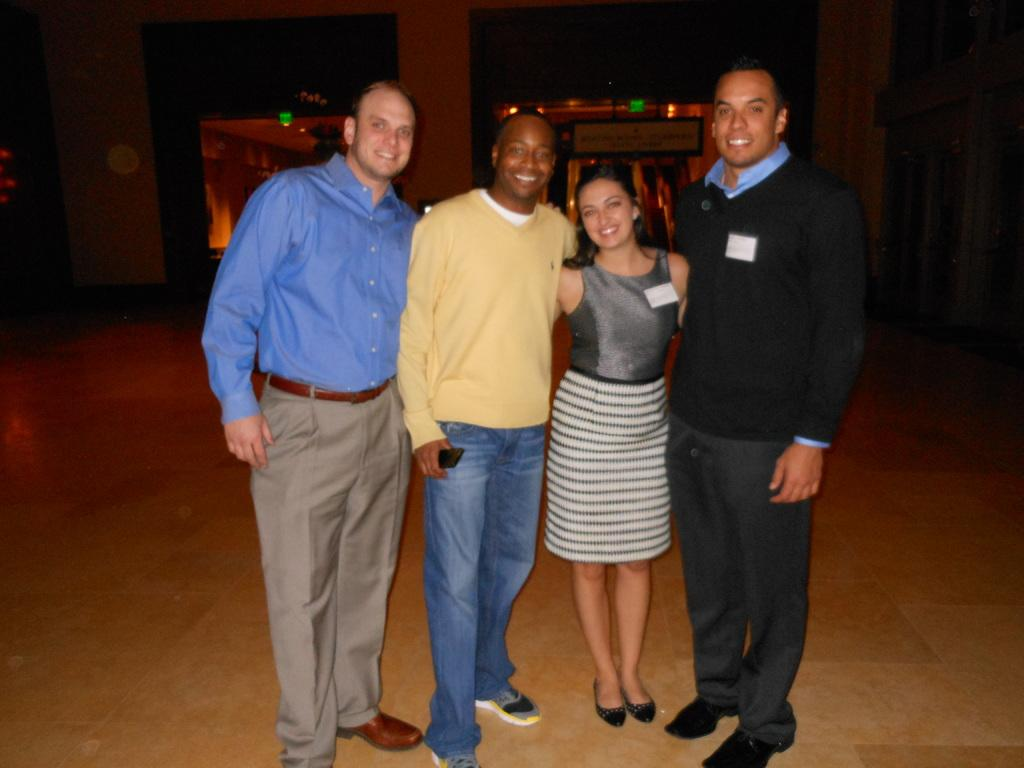How many people are in the image? There are three men and a woman in the image, making a total of four people. What are the people in the image doing? The people are standing and smiling, and they are posing for the picture. What can be seen in the background of the image? There is a building in the background of the image. What is the lighting condition in the image? There are lights visible in the dark background. What type of tax is being discussed in the image? There is no discussion of tax in the image; it features four people posing for a picture. What is the end result of the expansion mentioned in the image? There is no mention of expansion or any end result in the image. 